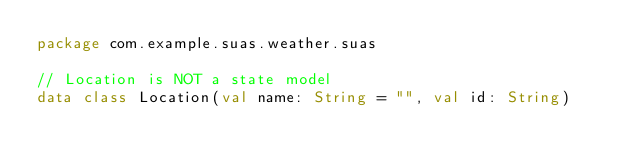<code> <loc_0><loc_0><loc_500><loc_500><_Kotlin_>package com.example.suas.weather.suas

// Location is NOT a state model
data class Location(val name: String = "", val id: String)</code> 